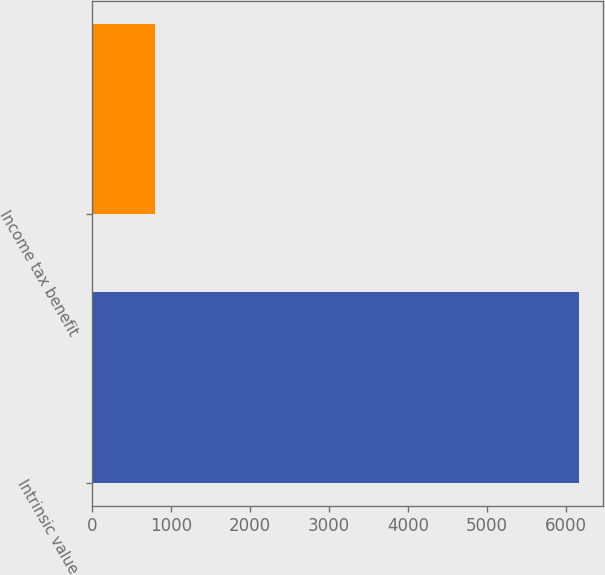Convert chart. <chart><loc_0><loc_0><loc_500><loc_500><bar_chart><fcel>Intrinsic value<fcel>Income tax benefit<nl><fcel>6159<fcel>799<nl></chart> 